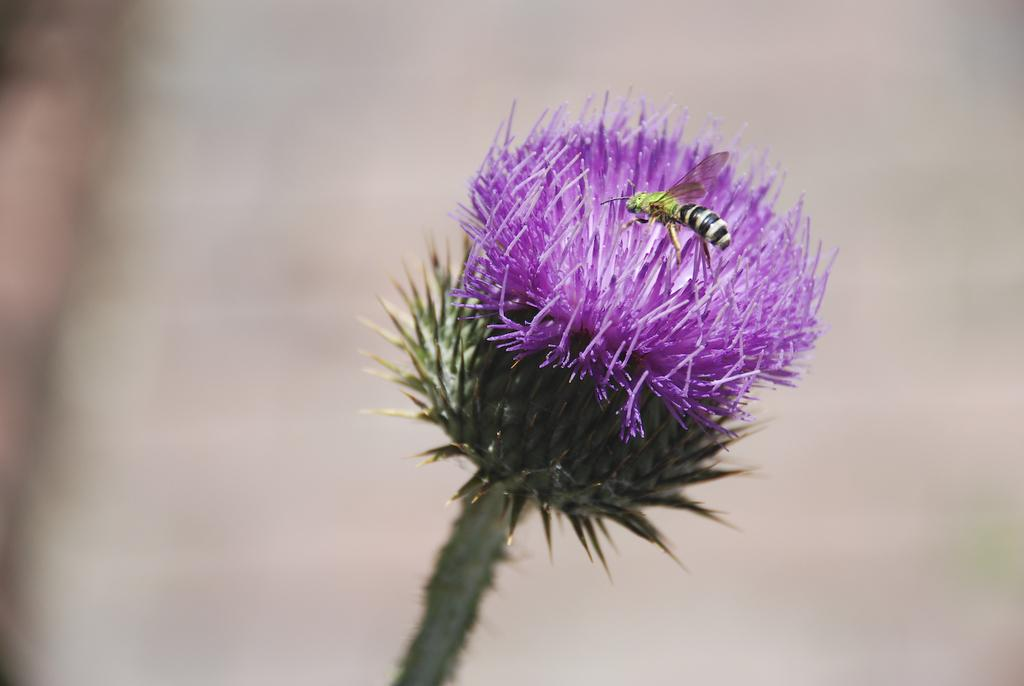What can be seen on the plant in the image? There is a flower on a plant in the image. Is there anything else on the flower? Yes, an insect is sitting on the flower. Can you describe the background of the image? The background of the image is blurred. What type of brush can be seen in the image? There is no brush present in the image. Is there any hair visible in the image? There is no hair visible in the image. 